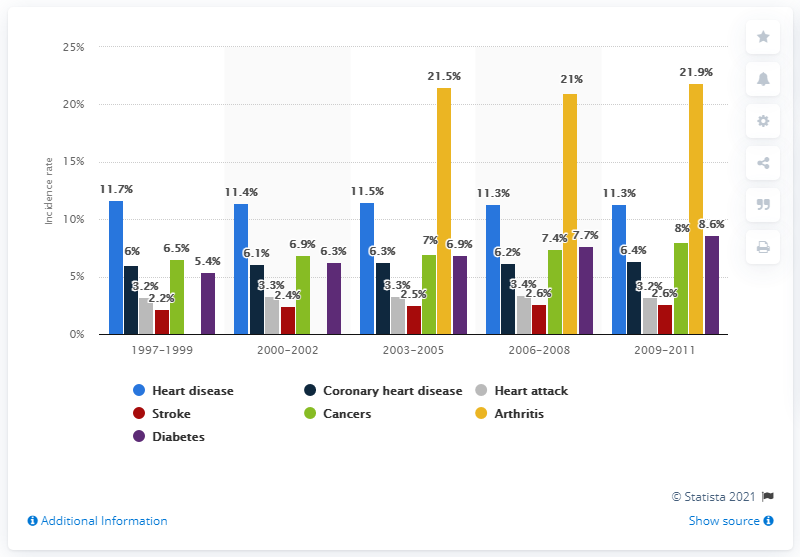Highlight a few significant elements in this photo. The incidence rate of heart disease between 2003 and 2005 was 11.5.. 